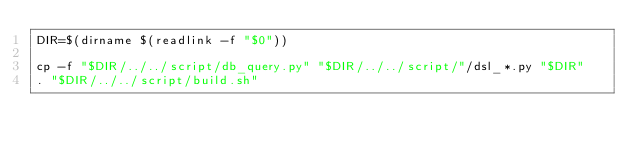Convert code to text. <code><loc_0><loc_0><loc_500><loc_500><_Bash_>DIR=$(dirname $(readlink -f "$0"))

cp -f "$DIR/../../script/db_query.py" "$DIR/../../script/"/dsl_*.py "$DIR"
. "$DIR/../../script/build.sh"
</code> 